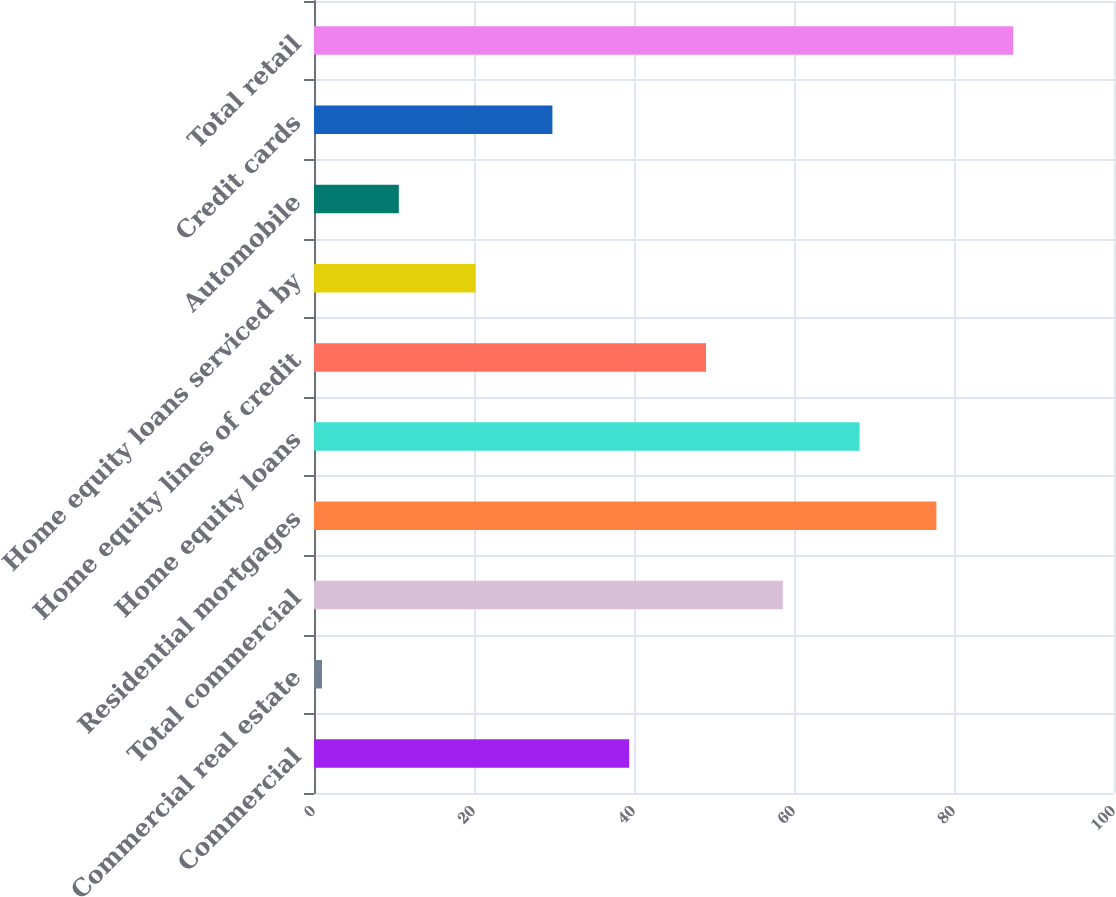<chart> <loc_0><loc_0><loc_500><loc_500><bar_chart><fcel>Commercial<fcel>Commercial real estate<fcel>Total commercial<fcel>Residential mortgages<fcel>Home equity loans<fcel>Home equity lines of credit<fcel>Home equity loans serviced by<fcel>Automobile<fcel>Credit cards<fcel>Total retail<nl><fcel>39.4<fcel>1<fcel>58.6<fcel>77.8<fcel>68.2<fcel>49<fcel>20.2<fcel>10.6<fcel>29.8<fcel>87.4<nl></chart> 